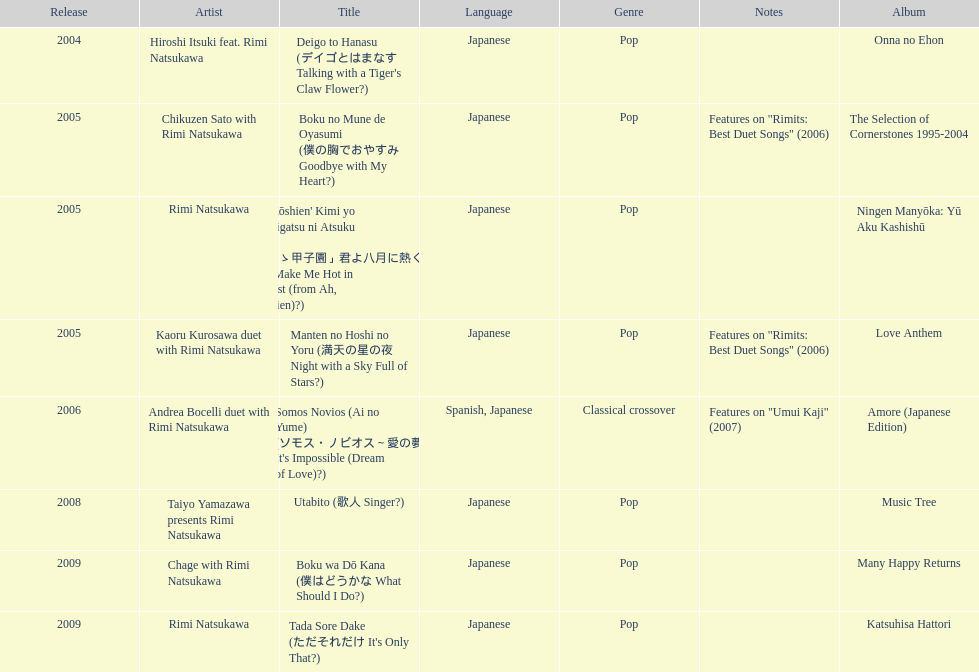Which year had the most titles released? 2005. 